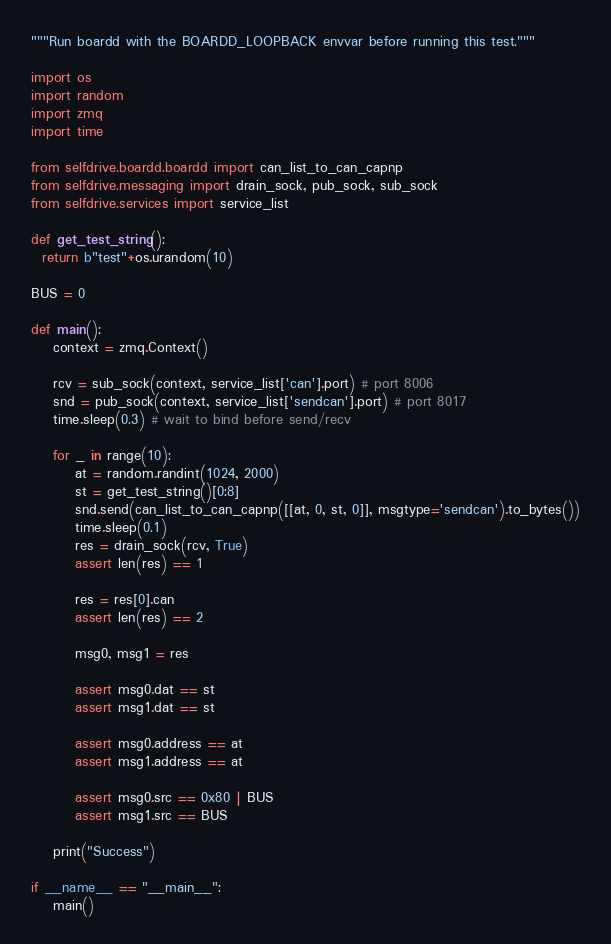Convert code to text. <code><loc_0><loc_0><loc_500><loc_500><_Python_>"""Run boardd with the BOARDD_LOOPBACK envvar before running this test."""

import os
import random
import zmq
import time

from selfdrive.boardd.boardd import can_list_to_can_capnp
from selfdrive.messaging import drain_sock, pub_sock, sub_sock
from selfdrive.services import service_list

def get_test_string():
  return b"test"+os.urandom(10)

BUS = 0

def main():
    context = zmq.Context()

    rcv = sub_sock(context, service_list['can'].port) # port 8006
    snd = pub_sock(context, service_list['sendcan'].port) # port 8017
    time.sleep(0.3) # wait to bind before send/recv

    for _ in range(10):
        at = random.randint(1024, 2000)
        st = get_test_string()[0:8]
        snd.send(can_list_to_can_capnp([[at, 0, st, 0]], msgtype='sendcan').to_bytes())
        time.sleep(0.1)
        res = drain_sock(rcv, True)
        assert len(res) == 1

        res = res[0].can
        assert len(res) == 2

        msg0, msg1 = res

        assert msg0.dat == st
        assert msg1.dat == st

        assert msg0.address == at
        assert msg1.address == at

        assert msg0.src == 0x80 | BUS
        assert msg1.src == BUS

    print("Success")

if __name__ == "__main__":
    main()
</code> 